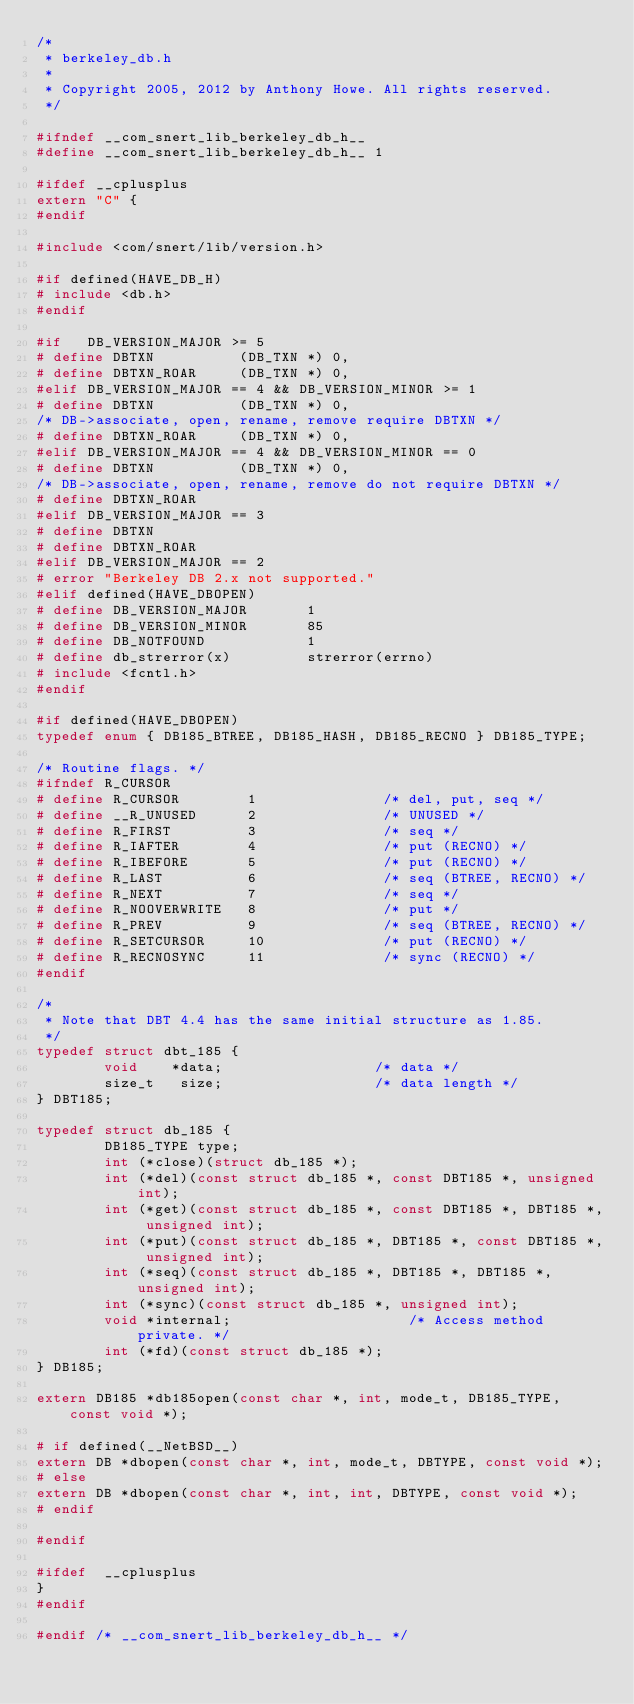<code> <loc_0><loc_0><loc_500><loc_500><_C_>/*
 * berkeley_db.h
 *
 * Copyright 2005, 2012 by Anthony Howe. All rights reserved.
 */

#ifndef __com_snert_lib_berkeley_db_h__
#define __com_snert_lib_berkeley_db_h__	1

#ifdef __cplusplus
extern "C" {
#endif

#include <com/snert/lib/version.h>

#if defined(HAVE_DB_H)
# include <db.h>
#endif

#if   DB_VERSION_MAJOR >= 5
# define DBTXN          (DB_TXN *) 0,
# define DBTXN_ROAR     (DB_TXN *) 0,
#elif DB_VERSION_MAJOR == 4 && DB_VERSION_MINOR >= 1
# define DBTXN          (DB_TXN *) 0,
/* DB->associate, open, rename, remove require DBTXN */
# define DBTXN_ROAR     (DB_TXN *) 0,
#elif DB_VERSION_MAJOR == 4 && DB_VERSION_MINOR == 0
# define DBTXN          (DB_TXN *) 0,
/* DB->associate, open, rename, remove do not require DBTXN */
# define DBTXN_ROAR
#elif DB_VERSION_MAJOR == 3
# define DBTXN
# define DBTXN_ROAR
#elif DB_VERSION_MAJOR == 2
# error "Berkeley DB 2.x not supported."
#elif defined(HAVE_DBOPEN)
# define DB_VERSION_MAJOR		1
# define DB_VERSION_MINOR		85
# define DB_NOTFOUND     		1
# define db_strerror(x)  		strerror(errno)
# include <fcntl.h>
#endif

#if defined(HAVE_DBOPEN)
typedef enum { DB185_BTREE, DB185_HASH, DB185_RECNO } DB185_TYPE;

/* Routine flags. */
#ifndef R_CURSOR
# define R_CURSOR        1               /* del, put, seq */
# define __R_UNUSED      2               /* UNUSED */
# define R_FIRST         3               /* seq */
# define R_IAFTER        4               /* put (RECNO) */
# define R_IBEFORE       5               /* put (RECNO) */
# define R_LAST          6               /* seq (BTREE, RECNO) */
# define R_NEXT          7               /* seq */
# define R_NOOVERWRITE   8               /* put */
# define R_PREV          9               /* seq (BTREE, RECNO) */
# define R_SETCURSOR     10              /* put (RECNO) */
# define R_RECNOSYNC     11              /* sync (RECNO) */
#endif

/*
 * Note that DBT 4.4 has the same initial structure as 1.85.
 */
typedef struct dbt_185 {
        void    *data;                  /* data */
        size_t   size;                  /* data length */
} DBT185;

typedef struct db_185 {
        DB185_TYPE type;
        int (*close)(struct db_185 *);
        int (*del)(const struct db_185 *, const DBT185 *, unsigned int);
        int (*get)(const struct db_185 *, const DBT185 *, DBT185 *, unsigned int);
        int (*put)(const struct db_185 *, DBT185 *, const DBT185 *, unsigned int);
        int (*seq)(const struct db_185 *, DBT185 *, DBT185 *, unsigned int);
        int (*sync)(const struct db_185 *, unsigned int);
        void *internal;                 	/* Access method private. */
        int (*fd)(const struct db_185 *);
} DB185;

extern DB185 *db185open(const char *, int, mode_t, DB185_TYPE, const void *);

# if defined(__NetBSD__)
extern DB *dbopen(const char *, int, mode_t, DBTYPE, const void *);
# else
extern DB *dbopen(const char *, int, int, DBTYPE, const void *);
# endif

#endif

#ifdef  __cplusplus
}
#endif

#endif /* __com_snert_lib_berkeley_db_h__ */
</code> 